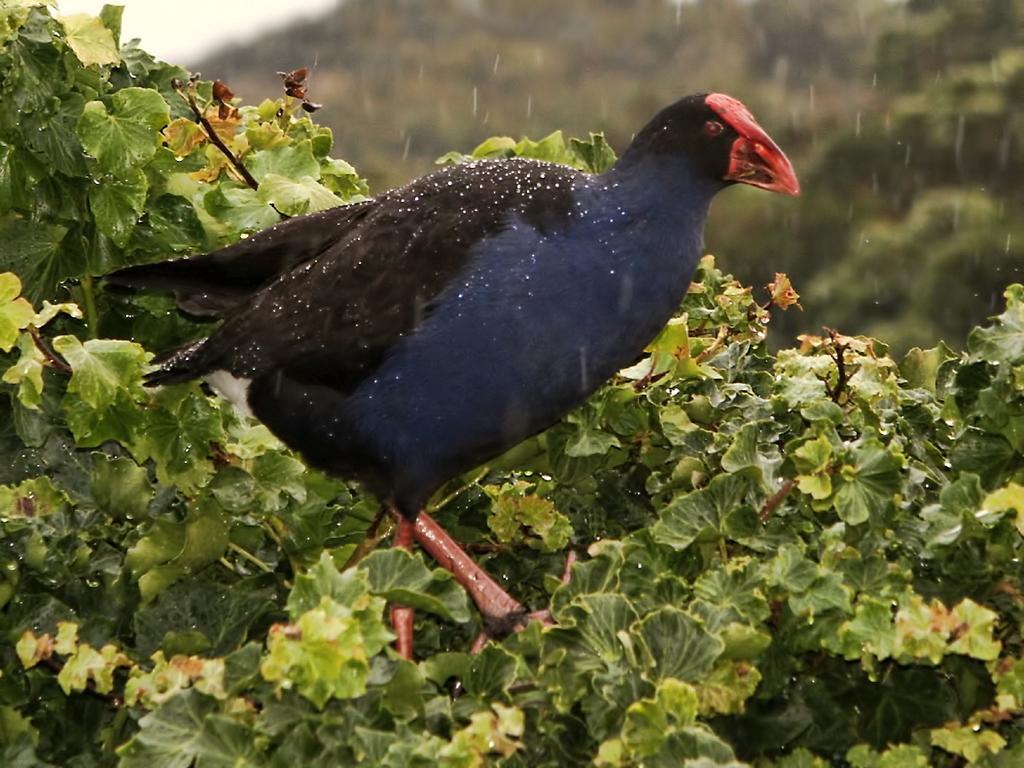Please provide a concise description of this image. In this image we can see a bird on the plants. 